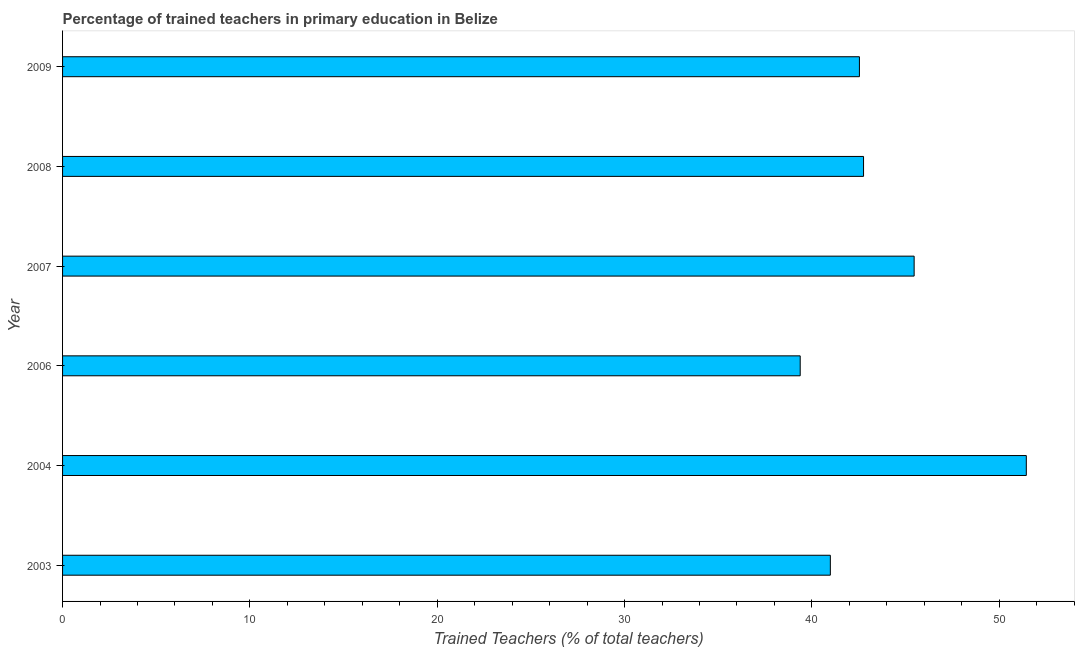Does the graph contain any zero values?
Offer a very short reply. No. Does the graph contain grids?
Provide a succinct answer. No. What is the title of the graph?
Offer a very short reply. Percentage of trained teachers in primary education in Belize. What is the label or title of the X-axis?
Ensure brevity in your answer.  Trained Teachers (% of total teachers). What is the percentage of trained teachers in 2003?
Your response must be concise. 40.99. Across all years, what is the maximum percentage of trained teachers?
Ensure brevity in your answer.  51.45. Across all years, what is the minimum percentage of trained teachers?
Provide a short and direct response. 39.38. In which year was the percentage of trained teachers maximum?
Make the answer very short. 2004. What is the sum of the percentage of trained teachers?
Make the answer very short. 262.56. What is the difference between the percentage of trained teachers in 2004 and 2008?
Keep it short and to the point. 8.69. What is the average percentage of trained teachers per year?
Your answer should be compact. 43.76. What is the median percentage of trained teachers?
Keep it short and to the point. 42.65. Do a majority of the years between 2006 and 2004 (inclusive) have percentage of trained teachers greater than 28 %?
Ensure brevity in your answer.  No. What is the ratio of the percentage of trained teachers in 2006 to that in 2008?
Make the answer very short. 0.92. Is the percentage of trained teachers in 2003 less than that in 2006?
Offer a very short reply. No. What is the difference between the highest and the second highest percentage of trained teachers?
Provide a succinct answer. 5.99. What is the difference between the highest and the lowest percentage of trained teachers?
Your answer should be very brief. 12.07. Are all the bars in the graph horizontal?
Give a very brief answer. Yes. What is the difference between two consecutive major ticks on the X-axis?
Ensure brevity in your answer.  10. What is the Trained Teachers (% of total teachers) in 2003?
Keep it short and to the point. 40.99. What is the Trained Teachers (% of total teachers) in 2004?
Your answer should be compact. 51.45. What is the Trained Teachers (% of total teachers) in 2006?
Provide a short and direct response. 39.38. What is the Trained Teachers (% of total teachers) in 2007?
Ensure brevity in your answer.  45.46. What is the Trained Teachers (% of total teachers) of 2008?
Your response must be concise. 42.76. What is the Trained Teachers (% of total teachers) of 2009?
Your response must be concise. 42.54. What is the difference between the Trained Teachers (% of total teachers) in 2003 and 2004?
Your answer should be very brief. -10.46. What is the difference between the Trained Teachers (% of total teachers) in 2003 and 2006?
Provide a succinct answer. 1.61. What is the difference between the Trained Teachers (% of total teachers) in 2003 and 2007?
Offer a very short reply. -4.47. What is the difference between the Trained Teachers (% of total teachers) in 2003 and 2008?
Offer a very short reply. -1.77. What is the difference between the Trained Teachers (% of total teachers) in 2003 and 2009?
Offer a terse response. -1.55. What is the difference between the Trained Teachers (% of total teachers) in 2004 and 2006?
Offer a terse response. 12.07. What is the difference between the Trained Teachers (% of total teachers) in 2004 and 2007?
Make the answer very short. 5.99. What is the difference between the Trained Teachers (% of total teachers) in 2004 and 2008?
Offer a terse response. 8.69. What is the difference between the Trained Teachers (% of total teachers) in 2004 and 2009?
Provide a succinct answer. 8.91. What is the difference between the Trained Teachers (% of total teachers) in 2006 and 2007?
Your response must be concise. -6.08. What is the difference between the Trained Teachers (% of total teachers) in 2006 and 2008?
Keep it short and to the point. -3.38. What is the difference between the Trained Teachers (% of total teachers) in 2006 and 2009?
Provide a short and direct response. -3.16. What is the difference between the Trained Teachers (% of total teachers) in 2007 and 2008?
Keep it short and to the point. 2.7. What is the difference between the Trained Teachers (% of total teachers) in 2007 and 2009?
Your response must be concise. 2.92. What is the difference between the Trained Teachers (% of total teachers) in 2008 and 2009?
Offer a very short reply. 0.22. What is the ratio of the Trained Teachers (% of total teachers) in 2003 to that in 2004?
Offer a very short reply. 0.8. What is the ratio of the Trained Teachers (% of total teachers) in 2003 to that in 2006?
Your answer should be compact. 1.04. What is the ratio of the Trained Teachers (% of total teachers) in 2003 to that in 2007?
Make the answer very short. 0.9. What is the ratio of the Trained Teachers (% of total teachers) in 2003 to that in 2008?
Your response must be concise. 0.96. What is the ratio of the Trained Teachers (% of total teachers) in 2004 to that in 2006?
Make the answer very short. 1.31. What is the ratio of the Trained Teachers (% of total teachers) in 2004 to that in 2007?
Keep it short and to the point. 1.13. What is the ratio of the Trained Teachers (% of total teachers) in 2004 to that in 2008?
Your answer should be very brief. 1.2. What is the ratio of the Trained Teachers (% of total teachers) in 2004 to that in 2009?
Ensure brevity in your answer.  1.21. What is the ratio of the Trained Teachers (% of total teachers) in 2006 to that in 2007?
Your answer should be very brief. 0.87. What is the ratio of the Trained Teachers (% of total teachers) in 2006 to that in 2008?
Your answer should be very brief. 0.92. What is the ratio of the Trained Teachers (% of total teachers) in 2006 to that in 2009?
Your response must be concise. 0.93. What is the ratio of the Trained Teachers (% of total teachers) in 2007 to that in 2008?
Offer a very short reply. 1.06. What is the ratio of the Trained Teachers (% of total teachers) in 2007 to that in 2009?
Ensure brevity in your answer.  1.07. What is the ratio of the Trained Teachers (% of total teachers) in 2008 to that in 2009?
Provide a short and direct response. 1. 